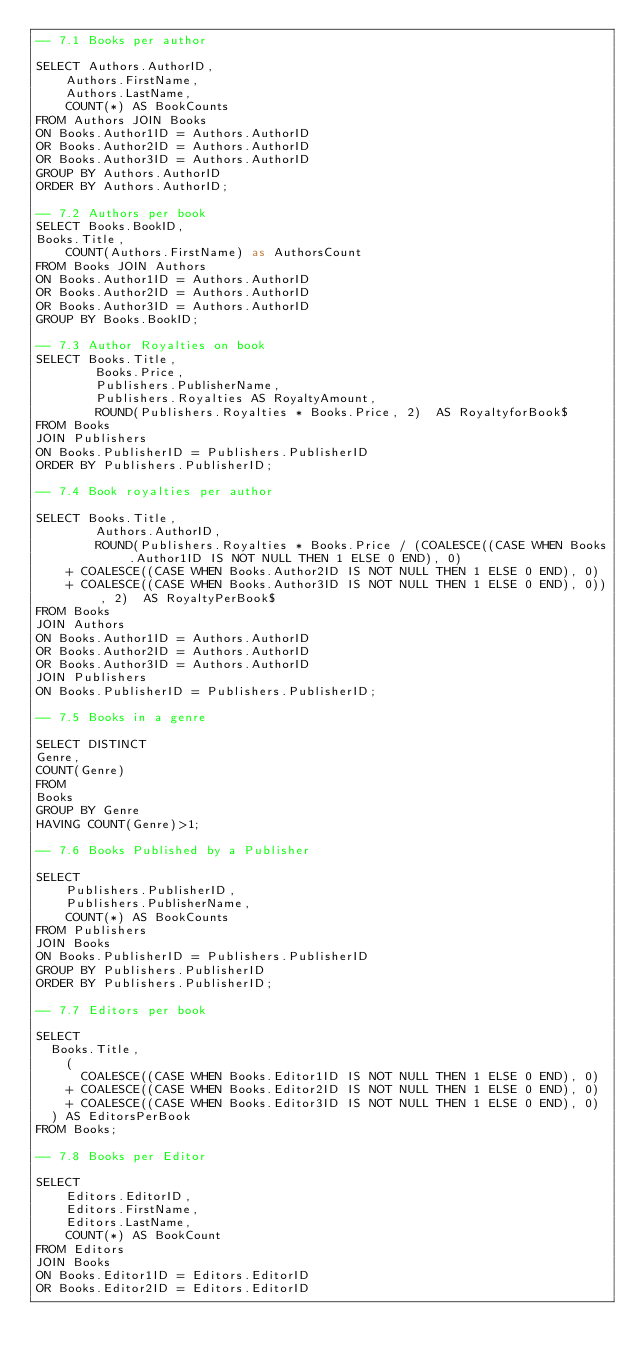<code> <loc_0><loc_0><loc_500><loc_500><_SQL_>-- 7.1 Books per author

SELECT Authors.AuthorID,
    Authors.FirstName,
    Authors.LastName,
    COUNT(*) AS BookCounts
FROM Authors JOIN Books
ON Books.Author1ID = Authors.AuthorID
OR Books.Author2ID = Authors.AuthorID
OR Books.Author3ID = Authors.AuthorID
GROUP BY Authors.AuthorID
ORDER BY Authors.AuthorID;

-- 7.2 Authors per book
SELECT Books.BookID,
Books.Title,
    COUNT(Authors.FirstName) as AuthorsCount
FROM Books JOIN Authors
ON Books.Author1ID = Authors.AuthorID
OR Books.Author2ID = Authors.AuthorID
OR Books.Author3ID = Authors.AuthorID
GROUP BY Books.BookID;

-- 7.3 Author Royalties on book
SELECT Books.Title, 
		Books.Price, 
        Publishers.PublisherName, 
        Publishers.Royalties AS RoyaltyAmount, 
        ROUND(Publishers.Royalties * Books.Price, 2)  AS RoyaltyforBook$
FROM Books
JOIN Publishers
ON Books.PublisherID = Publishers.PublisherID
ORDER BY Publishers.PublisherID;

-- 7.4 Book royalties per author

SELECT Books.Title,
		Authors.AuthorID,
        ROUND(Publishers.Royalties * Books.Price / (COALESCE((CASE WHEN Books.Author1ID IS NOT NULL THEN 1 ELSE 0 END), 0)
    + COALESCE((CASE WHEN Books.Author2ID IS NOT NULL THEN 1 ELSE 0 END), 0)
    + COALESCE((CASE WHEN Books.Author3ID IS NOT NULL THEN 1 ELSE 0 END), 0)), 2)  AS RoyaltyPerBook$
FROM Books
JOIN Authors 
ON Books.Author1ID = Authors.AuthorID
OR Books.Author2ID = Authors.AuthorID
OR Books.Author3ID = Authors.AuthorID
JOIN Publishers
ON Books.PublisherID = Publishers.PublisherID;

-- 7.5 Books in a genre

SELECT DISTINCT
Genre,
COUNT(Genre)
FROM 
Books
GROUP BY Genre
HAVING COUNT(Genre)>1;

-- 7.6 Books Published by a Publisher

SELECT 
	Publishers.PublisherID,
    Publishers.PublisherName,
    COUNT(*) AS BookCounts
FROM Publishers
JOIN Books
ON Books.PublisherID = Publishers.PublisherID
GROUP BY Publishers.PublisherID
ORDER BY Publishers.PublisherID;

-- 7.7 Editors per book

SELECT
  Books.Title,
	(
      COALESCE((CASE WHEN Books.Editor1ID IS NOT NULL THEN 1 ELSE 0 END), 0)
    + COALESCE((CASE WHEN Books.Editor2ID IS NOT NULL THEN 1 ELSE 0 END), 0)
    + COALESCE((CASE WHEN Books.Editor3ID IS NOT NULL THEN 1 ELSE 0 END), 0)
  ) AS EditorsPerBook
FROM Books;

-- 7.8 Books per Editor

SELECT 
	Editors.EditorID,
    Editors.FirstName,
    Editors.LastName,
    COUNT(*) AS BookCount
FROM Editors
JOIN Books
ON Books.Editor1ID = Editors.EditorID
OR Books.Editor2ID = Editors.EditorID</code> 